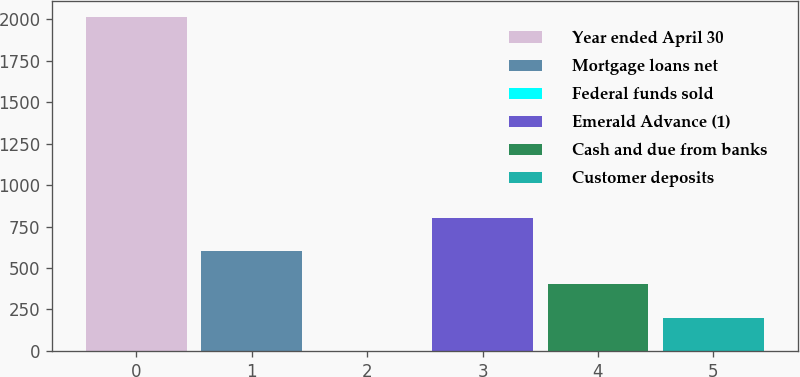Convert chart to OTSL. <chart><loc_0><loc_0><loc_500><loc_500><bar_chart><fcel>Year ended April 30<fcel>Mortgage loans net<fcel>Federal funds sold<fcel>Emerald Advance (1)<fcel>Cash and due from banks<fcel>Customer deposits<nl><fcel>2011<fcel>603.37<fcel>0.1<fcel>804.46<fcel>402.28<fcel>201.19<nl></chart> 